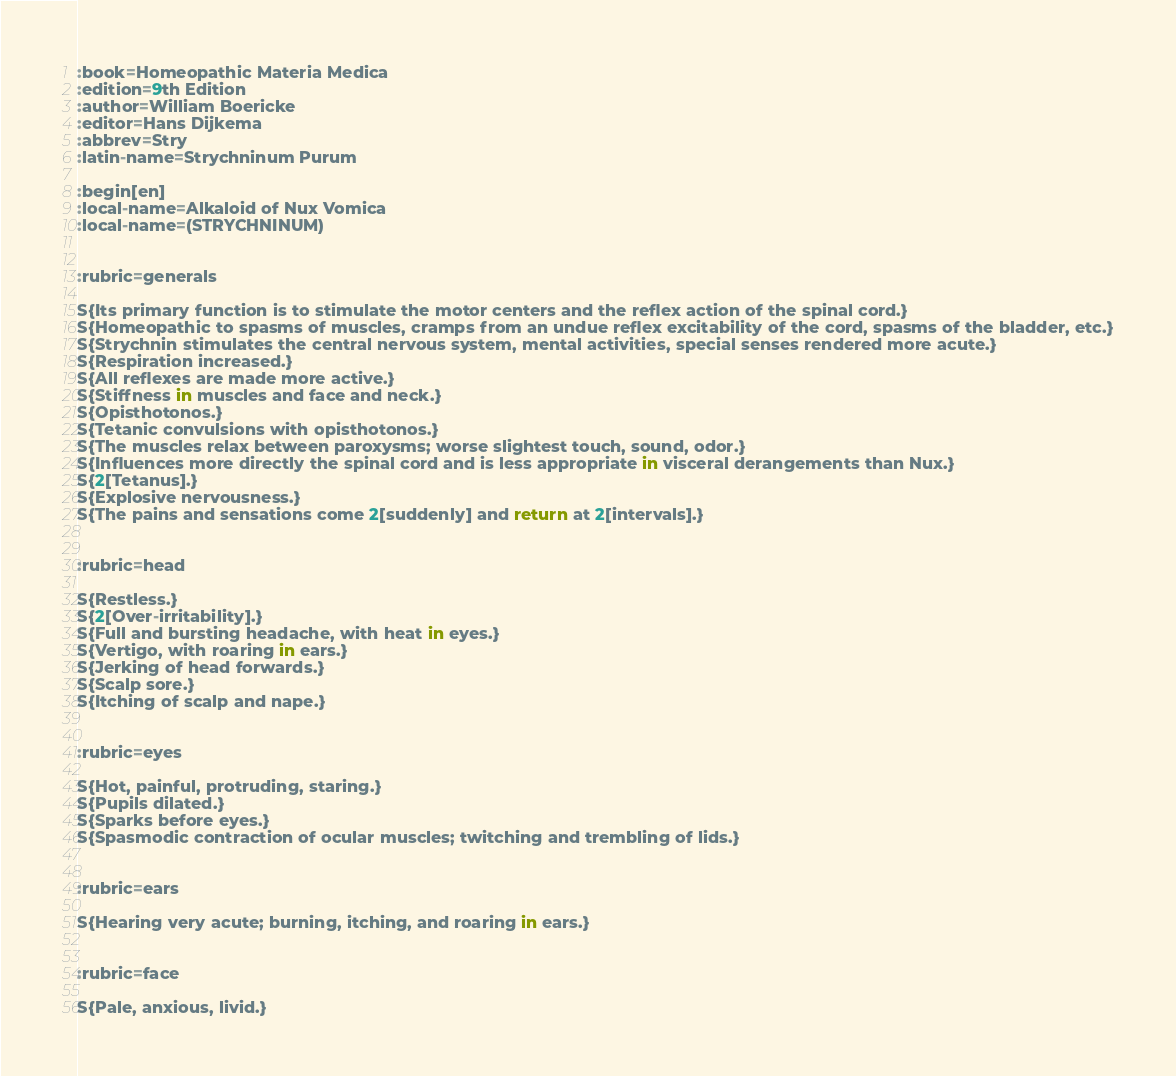<code> <loc_0><loc_0><loc_500><loc_500><_ObjectiveC_>:book=Homeopathic Materia Medica
:edition=9th Edition
:author=William Boericke
:editor=Hans Dijkema
:abbrev=Stry
:latin-name=Strychninum Purum

:begin[en]
:local-name=Alkaloid of Nux Vomica
:local-name=(STRYCHNINUM)


:rubric=generals

S{Its primary function is to stimulate the motor centers and the reflex action of the spinal cord.}
S{Homeopathic to spasms of muscles, cramps from an undue reflex excitability of the cord, spasms of the bladder, etc.}
S{Strychnin stimulates the central nervous system, mental activities, special senses rendered more acute.}
S{Respiration increased.}
S{All reflexes are made more active.}
S{Stiffness in muscles and face and neck.}
S{Opisthotonos.}
S{Tetanic convulsions with opisthotonos.}
S{The muscles relax between paroxysms; worse slightest touch, sound, odor.}
S{Influences more directly the spinal cord and is less appropriate in visceral derangements than Nux.}
S{2[Tetanus].}
S{Explosive nervousness.}
S{The pains and sensations come 2[suddenly] and return at 2[intervals].}


:rubric=head

S{Restless.}
S{2[Over-irritability].}
S{Full and bursting headache, with heat in eyes.}
S{Vertigo, with roaring in ears.}
S{Jerking of head forwards.}
S{Scalp sore.}
S{Itching of scalp and nape.}


:rubric=eyes

S{Hot, painful, protruding, staring.}
S{Pupils dilated.}
S{Sparks before eyes.}
S{Spasmodic contraction of ocular muscles; twitching and trembling of lids.}


:rubric=ears

S{Hearing very acute; burning, itching, and roaring in ears.}


:rubric=face

S{Pale, anxious, livid.}</code> 